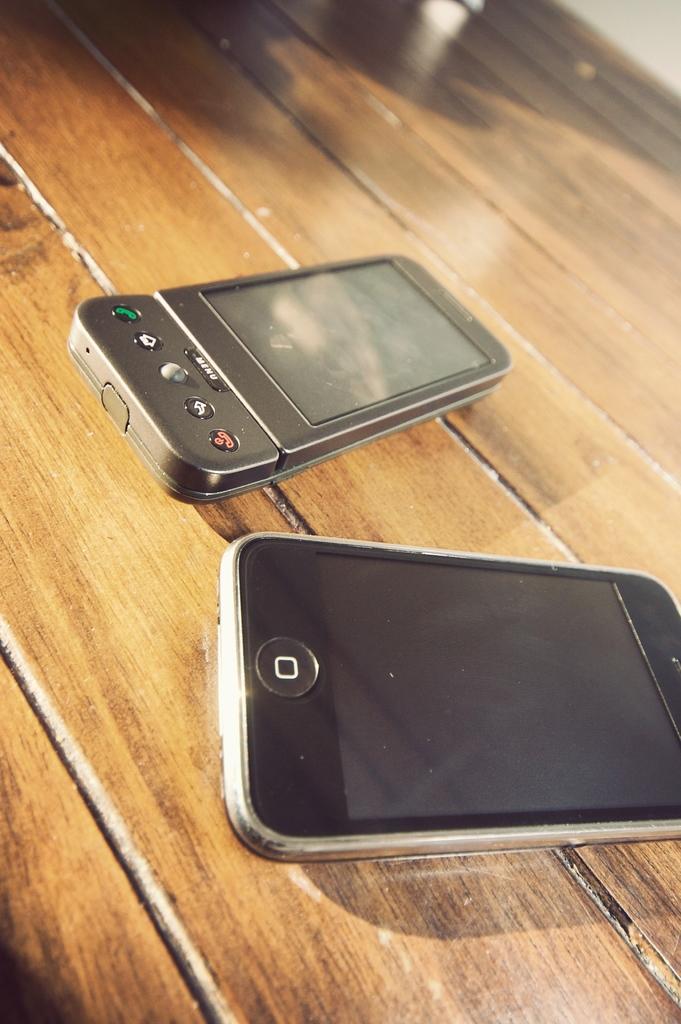Please provide a concise description of this image. In this image there is a wooden table on which there are two mobiles one beside the other. 